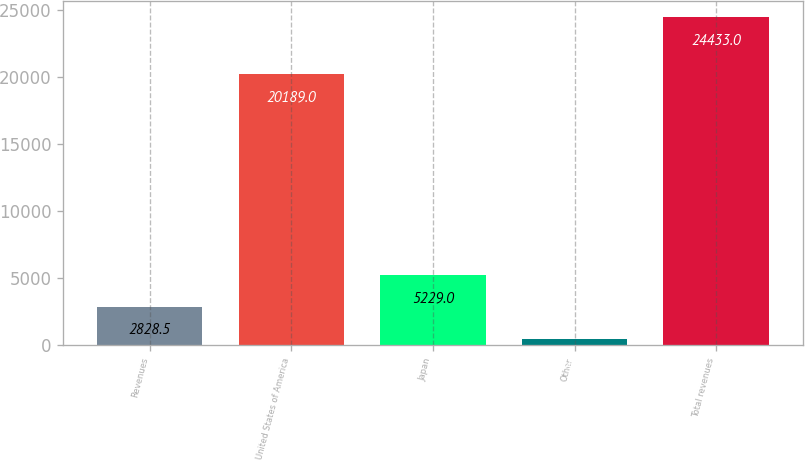Convert chart. <chart><loc_0><loc_0><loc_500><loc_500><bar_chart><fcel>Revenues<fcel>United States of America<fcel>Japan<fcel>Other<fcel>Total revenues<nl><fcel>2828.5<fcel>20189<fcel>5229<fcel>428<fcel>24433<nl></chart> 